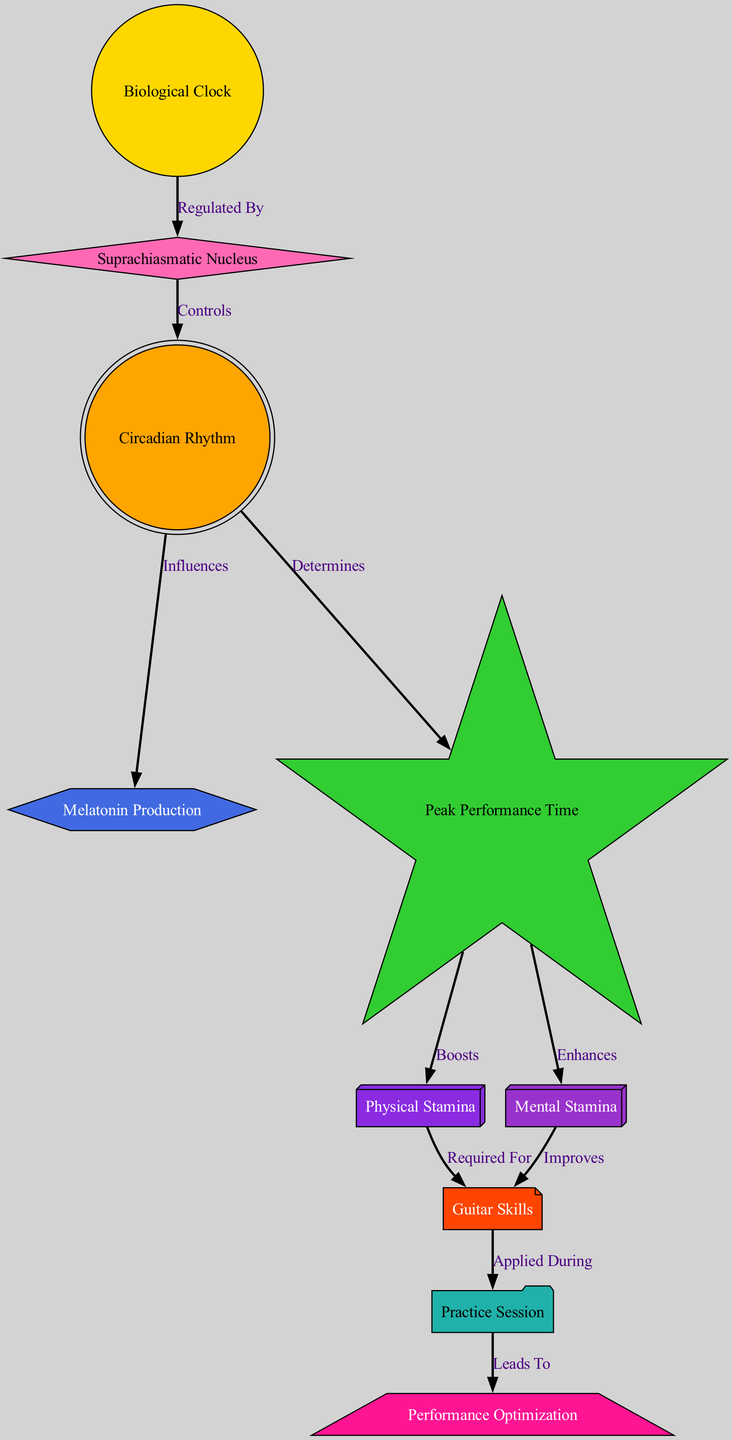What is the primary regulator of the biological clock? The diagram indicates that the "Suprachiasmatic Nucleus" regulates the "Biological Clock." This relationship is shown by the directed edge labeled "Regulated By" from "Biological Clock" to "Suprachiasmatic Nucleus."
Answer: Suprachiasmatic Nucleus How many nodes are in the diagram? The diagram contains 10 distinct nodes depicted as different concepts related to circadian rhythms and performance which can be counted visually. This total was derived from listing out each node.
Answer: 10 What does the circadian rhythm influence? According to the diagram, the "Circadian Rhythm" influences "Melatonin Production." This relationship is shown by the directed edge labeled "Influences" going from "Circadian Rhythm" to "Melatonin Production." In addition, it also influences "Peak Performance Time."
Answer: Melatonin Production and Peak Performance Time Which factor is boosted by peak performance time? The diagram shows that "Physical Stamina" is boosted by "Peak Performance Time." This is established through the directed edge labeled "Boosts" from "Peak Performance Time" to "Physical Stamina."
Answer: Physical Stamina How do mental stamina and physical stamina contribute to guitar skills? The diagram clearly indicates that both "Mental Stamina" and "Physical Stamina" are connected to "Guitar Skills." Specifically, "Physical Stamina" is "Required For" "Guitar Skills," while "Mental Stamina" "Improves" "Guitar Skills." Therefore, both elements contribute to guitar skills in different ways.
Answer: Required For and Improves What leads to performance optimization? The diagram illustrates that a "Practice Session" leads to "Performance Optimization." This is shown through the directed edge labeled "Leads To" from "Practice Session" to "Performance Optimization."
Answer: Practice Session Which node determines peak performance time? The diagram states that "Circadian Rhythm" determines "Peak Performance Time," as represented by the directed edge labeled "Determines" from "Circadian Rhythm" to "Peak Performance Time."
Answer: Circadian Rhythm What shapes are used to represent peak performance time and guitar skills? In the diagram, "Peak Performance Time" is represented with a "star" shape, while "Guitar Skills" is illustrated using a "note" shape. The shape designations are explicitly specified in their visual characteristics.
Answer: Star and Note How does physical stamina affect practice sessions? The diagram shows that "Physical Stamina" is "Required For" "Guitar Skills," which are subsequently "Applied During" a "Practice Session." This connection shows that physical stamina is essential for effectively practicing guitar skills.
Answer: Required For Guitar Skills 